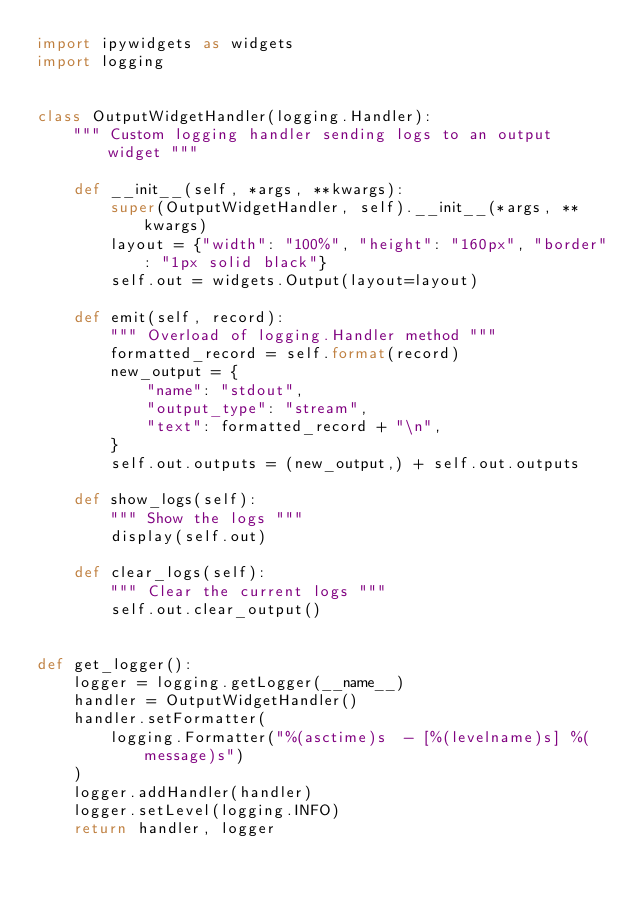<code> <loc_0><loc_0><loc_500><loc_500><_Python_>import ipywidgets as widgets
import logging


class OutputWidgetHandler(logging.Handler):
    """ Custom logging handler sending logs to an output widget """

    def __init__(self, *args, **kwargs):
        super(OutputWidgetHandler, self).__init__(*args, **kwargs)
        layout = {"width": "100%", "height": "160px", "border": "1px solid black"}
        self.out = widgets.Output(layout=layout)

    def emit(self, record):
        """ Overload of logging.Handler method """
        formatted_record = self.format(record)
        new_output = {
            "name": "stdout",
            "output_type": "stream",
            "text": formatted_record + "\n",
        }
        self.out.outputs = (new_output,) + self.out.outputs

    def show_logs(self):
        """ Show the logs """
        display(self.out)

    def clear_logs(self):
        """ Clear the current logs """
        self.out.clear_output()


def get_logger():
    logger = logging.getLogger(__name__)
    handler = OutputWidgetHandler()
    handler.setFormatter(
        logging.Formatter("%(asctime)s  - [%(levelname)s] %(message)s")
    )
    logger.addHandler(handler)
    logger.setLevel(logging.INFO)
    return handler, logger
</code> 